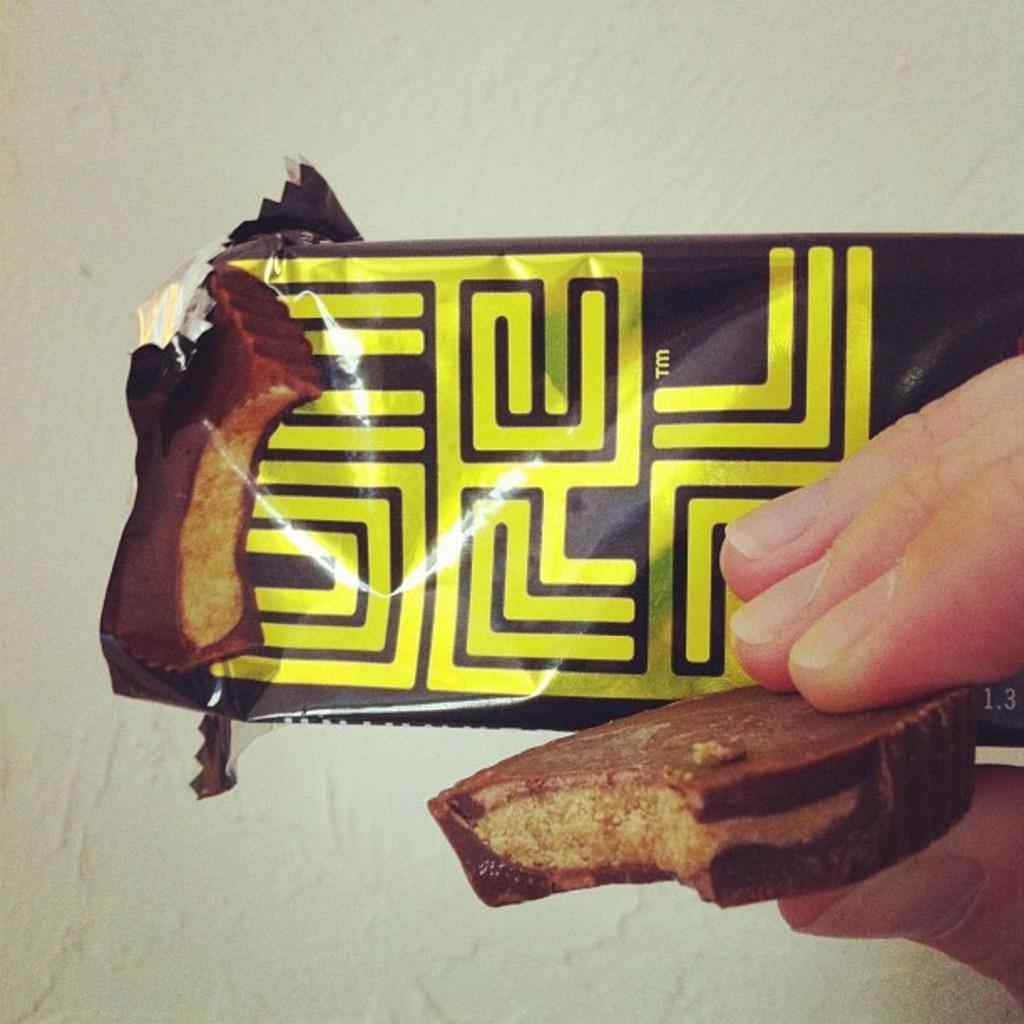How would you summarize this image in a sentence or two? In this picture we can observe a cover which is in brown and yellow color. There is a biscuit in the hand of a human. In the background there is a wall which is in white color. 